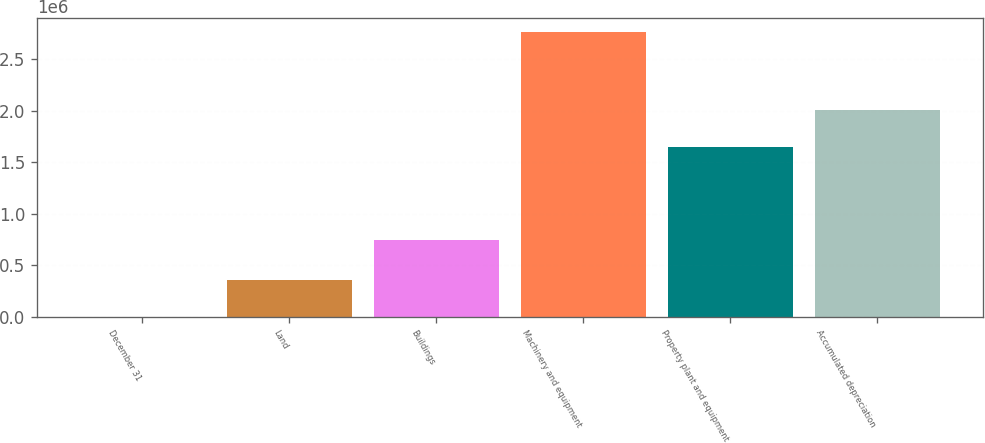Convert chart. <chart><loc_0><loc_0><loc_500><loc_500><bar_chart><fcel>December 31<fcel>Land<fcel>Buildings<fcel>Machinery and equipment<fcel>Property plant and equipment<fcel>Accumulated depreciation<nl><fcel>2006<fcel>361581<fcel>746198<fcel>2.76482e+06<fcel>1.6513e+06<fcel>2.01088e+06<nl></chart> 